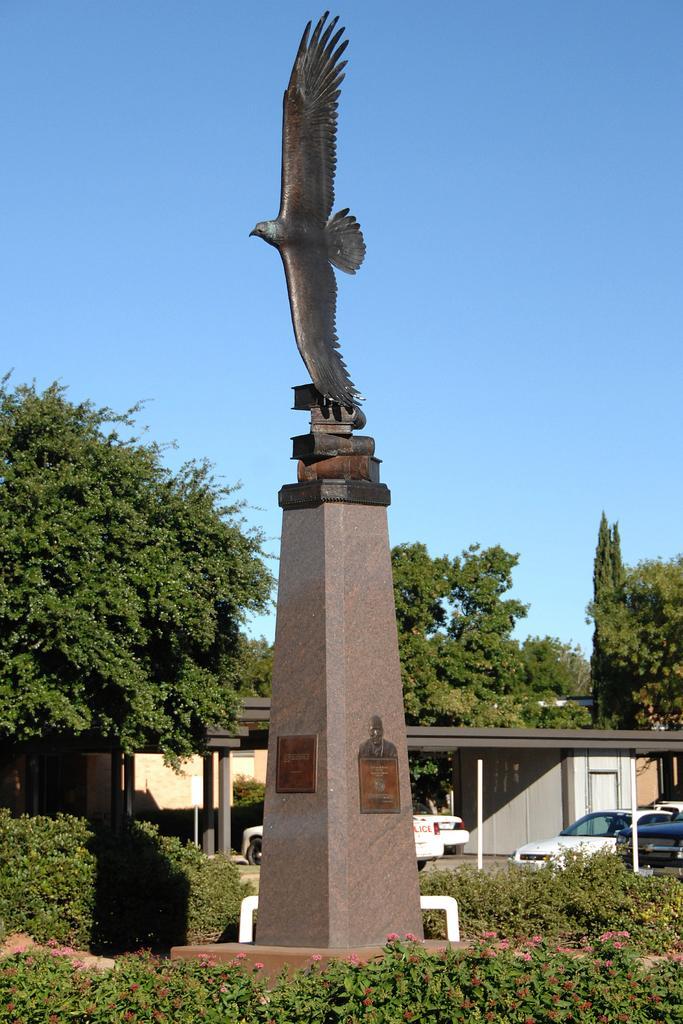Describe this image in one or two sentences. In this image there are plants with flowers, shed, vehicles, trees, a statue of a bird on the pillar , and in the background there is sky. 